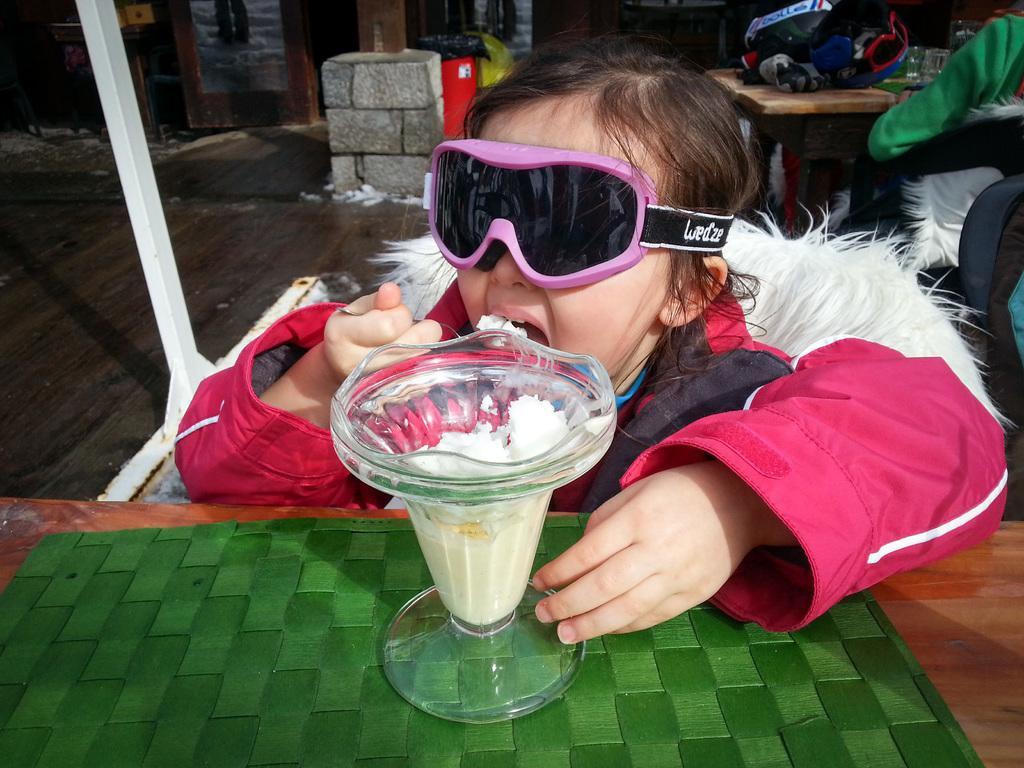Could you give a brief overview of what you see in this image? There is a girl wearing jacket and holding a spoon with ice cream. In front of her there is a table. On that there is a glass with ice cream. She is wearing a swimming goggles. In the back there is a table. On that there are many items. 